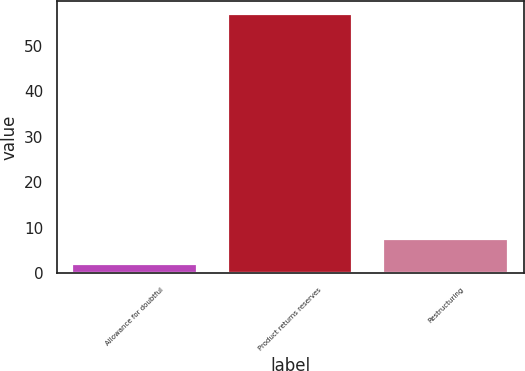<chart> <loc_0><loc_0><loc_500><loc_500><bar_chart><fcel>Allowance for doubtful<fcel>Product returns reserves<fcel>Restructuring<nl><fcel>2.1<fcel>57.1<fcel>7.6<nl></chart> 